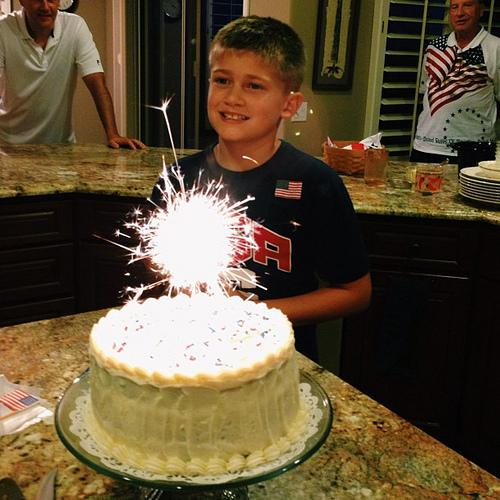Question: what is the color of the cake?
Choices:
A. Yellow.
B. White.
C. Black.
D. Brown.
Answer with the letter. Answer: B Question: who is wearing black shirt?
Choices:
A. The girl.
B. The man.
C. The boy.
D. The woman.
Answer with the letter. Answer: C Question: what is the occasion?
Choices:
A. Retirement party.
B. Graduation.
C. Wedding.
D. Birthday.
Answer with the letter. Answer: D Question: what is on the table?
Choices:
A. Cake.
B. Salad.
C. Wine.
D. Soup.
Answer with the letter. Answer: A Question: where is the cake?
Choices:
A. On the table.
B. In the fridge.
C. In the box.
D. On the platter.
Answer with the letter. Answer: A 